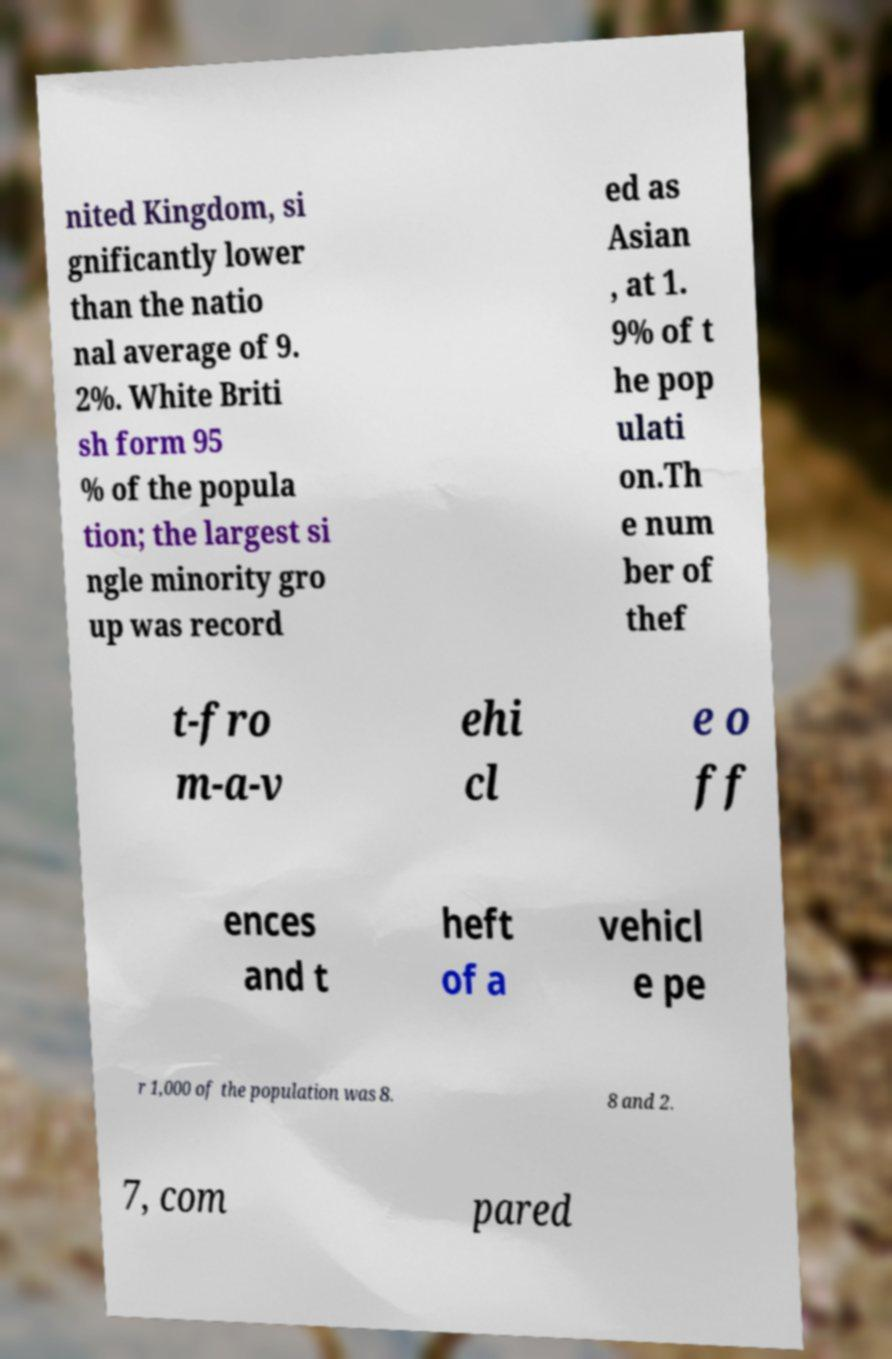Can you read and provide the text displayed in the image?This photo seems to have some interesting text. Can you extract and type it out for me? nited Kingdom, si gnificantly lower than the natio nal average of 9. 2%. White Briti sh form 95 % of the popula tion; the largest si ngle minority gro up was record ed as Asian , at 1. 9% of t he pop ulati on.Th e num ber of thef t-fro m-a-v ehi cl e o ff ences and t heft of a vehicl e pe r 1,000 of the population was 8. 8 and 2. 7, com pared 